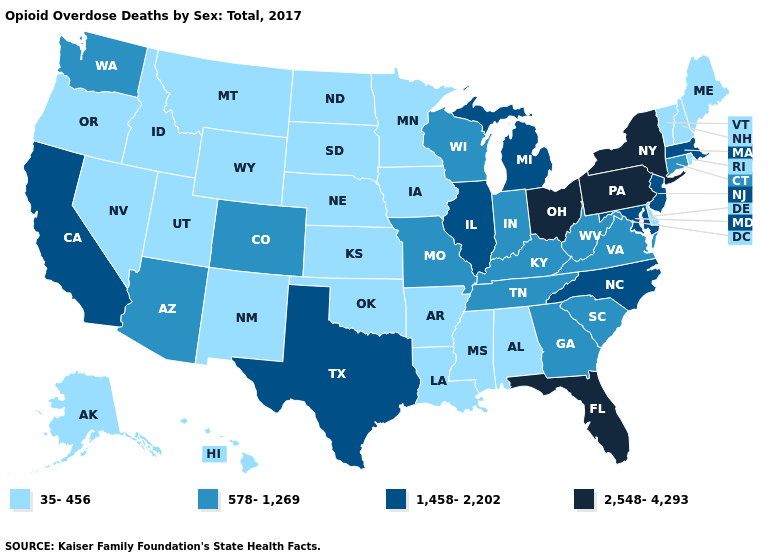What is the value of California?
Concise answer only. 1,458-2,202. Name the states that have a value in the range 35-456?
Write a very short answer. Alabama, Alaska, Arkansas, Delaware, Hawaii, Idaho, Iowa, Kansas, Louisiana, Maine, Minnesota, Mississippi, Montana, Nebraska, Nevada, New Hampshire, New Mexico, North Dakota, Oklahoma, Oregon, Rhode Island, South Dakota, Utah, Vermont, Wyoming. What is the value of North Dakota?
Keep it brief. 35-456. What is the value of South Dakota?
Be succinct. 35-456. Which states have the highest value in the USA?
Concise answer only. Florida, New York, Ohio, Pennsylvania. Does Colorado have the lowest value in the West?
Be succinct. No. Which states have the lowest value in the USA?
Be succinct. Alabama, Alaska, Arkansas, Delaware, Hawaii, Idaho, Iowa, Kansas, Louisiana, Maine, Minnesota, Mississippi, Montana, Nebraska, Nevada, New Hampshire, New Mexico, North Dakota, Oklahoma, Oregon, Rhode Island, South Dakota, Utah, Vermont, Wyoming. What is the value of Arizona?
Give a very brief answer. 578-1,269. What is the highest value in the South ?
Answer briefly. 2,548-4,293. Does the first symbol in the legend represent the smallest category?
Keep it brief. Yes. Does Louisiana have a higher value than North Dakota?
Keep it brief. No. Name the states that have a value in the range 35-456?
Keep it brief. Alabama, Alaska, Arkansas, Delaware, Hawaii, Idaho, Iowa, Kansas, Louisiana, Maine, Minnesota, Mississippi, Montana, Nebraska, Nevada, New Hampshire, New Mexico, North Dakota, Oklahoma, Oregon, Rhode Island, South Dakota, Utah, Vermont, Wyoming. What is the value of Alabama?
Write a very short answer. 35-456. Does Ohio have the highest value in the MidWest?
Be succinct. Yes. Name the states that have a value in the range 1,458-2,202?
Give a very brief answer. California, Illinois, Maryland, Massachusetts, Michigan, New Jersey, North Carolina, Texas. 